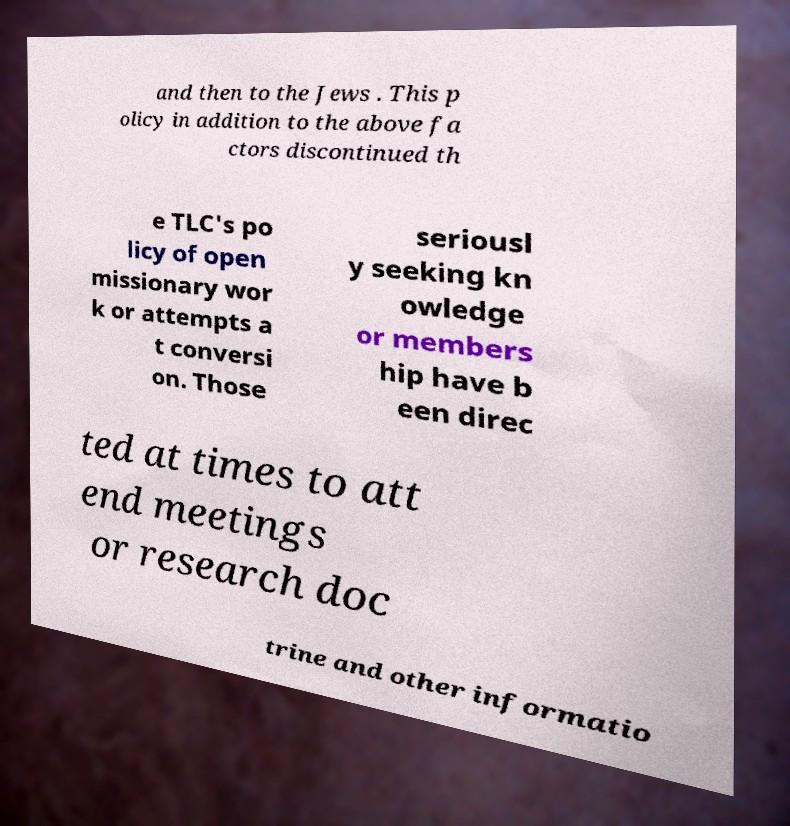Can you read and provide the text displayed in the image?This photo seems to have some interesting text. Can you extract and type it out for me? and then to the Jews . This p olicy in addition to the above fa ctors discontinued th e TLC's po licy of open missionary wor k or attempts a t conversi on. Those seriousl y seeking kn owledge or members hip have b een direc ted at times to att end meetings or research doc trine and other informatio 